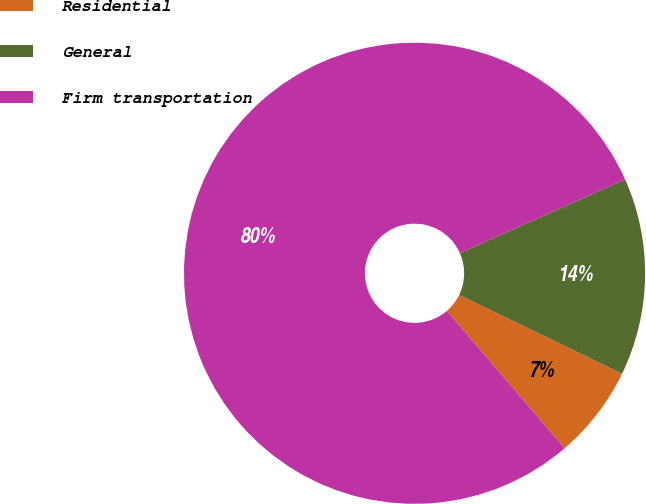Convert chart. <chart><loc_0><loc_0><loc_500><loc_500><pie_chart><fcel>Residential<fcel>General<fcel>Firm transportation<nl><fcel>6.54%<fcel>13.85%<fcel>79.61%<nl></chart> 